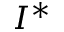Convert formula to latex. <formula><loc_0><loc_0><loc_500><loc_500>I ^ { * }</formula> 